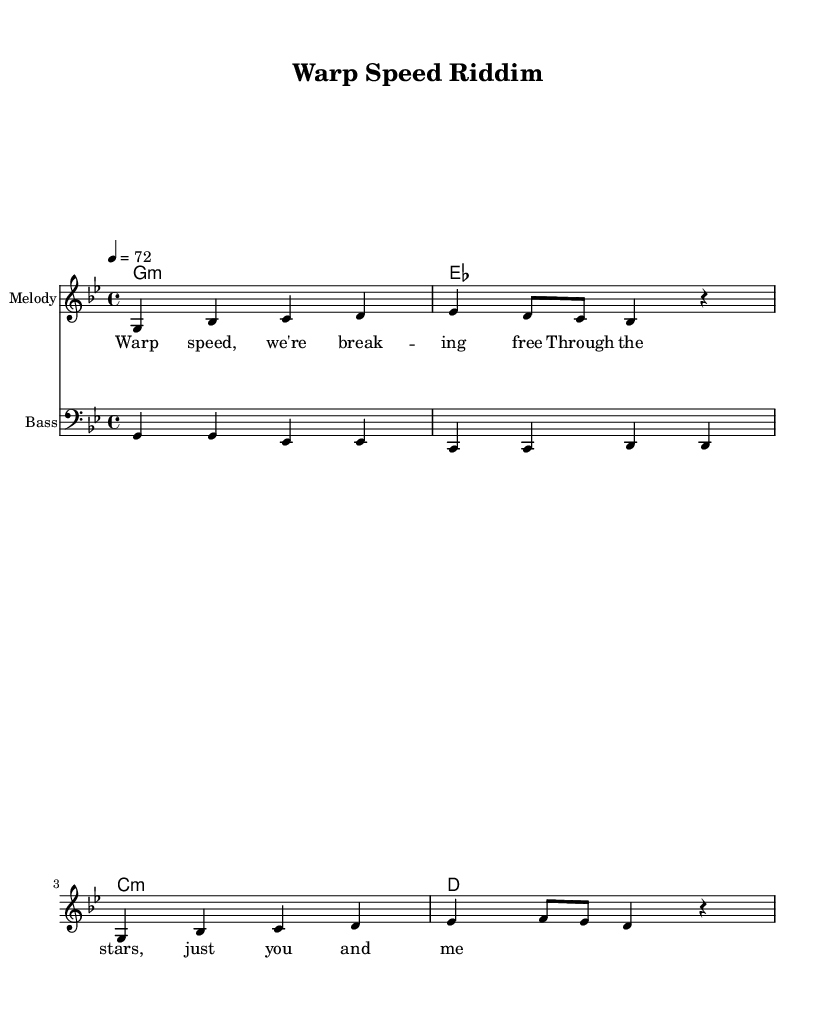What is the key signature of this music? The key signature is indicated by the sharp or flat signs present at the beginning of the staff. In this case, there are two flats, which indicates the key signature of G minor.
Answer: G minor What is the time signature of this piece? The time signature is displayed at the beginning of the staff, represented as a fraction. Here, it shows 4 over 4, indicating that there are four beats per measure.
Answer: 4/4 What is the tempo marking of the music? The tempo marking indicates the speed of the piece, usually provided in beats per minute. In this sheet music, it shows the tempo as "4 = 72," meaning there are 72 beats in a minute.
Answer: 72 How many measures are in the melody section? The melody is divided into measures by vertical lines, and by counting these lines, we find that there are four measures in total in the melody section.
Answer: 4 What is the main theme of the lyrics? The lyrics provide insight into the song's theme, which, from the provided text, expresses a feeling of freedom and exploration in space. The mention of "Warp speed" suggests a journey beyond the ordinary, emphasizing exploration.
Answer: Space exploration How many notes are in the bass line of the first measure? The bass line note values are marked within the measures. By examining the first measure, there are two notes played (both "G"), each given a quarter note value. Thus, there are two notes in the first measure.
Answer: 2 What type of music does this sheet represent? The style of the music can often be identified through the lyrical content and the rhythm. Given the title "Warp Speed Riddim," along with the reggae-inspired rhythm and themes of exploration, it is clearly representative of the reggae genre.
Answer: Reggae 